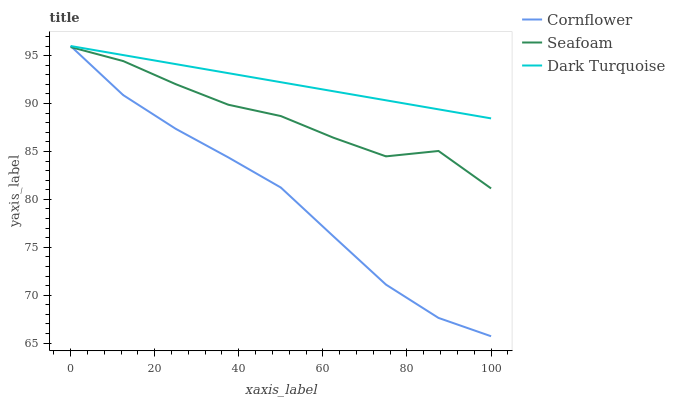Does Cornflower have the minimum area under the curve?
Answer yes or no. Yes. Does Dark Turquoise have the maximum area under the curve?
Answer yes or no. Yes. Does Seafoam have the minimum area under the curve?
Answer yes or no. No. Does Seafoam have the maximum area under the curve?
Answer yes or no. No. Is Dark Turquoise the smoothest?
Answer yes or no. Yes. Is Seafoam the roughest?
Answer yes or no. Yes. Is Seafoam the smoothest?
Answer yes or no. No. Is Dark Turquoise the roughest?
Answer yes or no. No. Does Cornflower have the lowest value?
Answer yes or no. Yes. Does Seafoam have the lowest value?
Answer yes or no. No. Does Dark Turquoise have the highest value?
Answer yes or no. Yes. Does Seafoam have the highest value?
Answer yes or no. No. Is Seafoam less than Dark Turquoise?
Answer yes or no. Yes. Is Dark Turquoise greater than Seafoam?
Answer yes or no. Yes. Does Seafoam intersect Cornflower?
Answer yes or no. Yes. Is Seafoam less than Cornflower?
Answer yes or no. No. Is Seafoam greater than Cornflower?
Answer yes or no. No. Does Seafoam intersect Dark Turquoise?
Answer yes or no. No. 